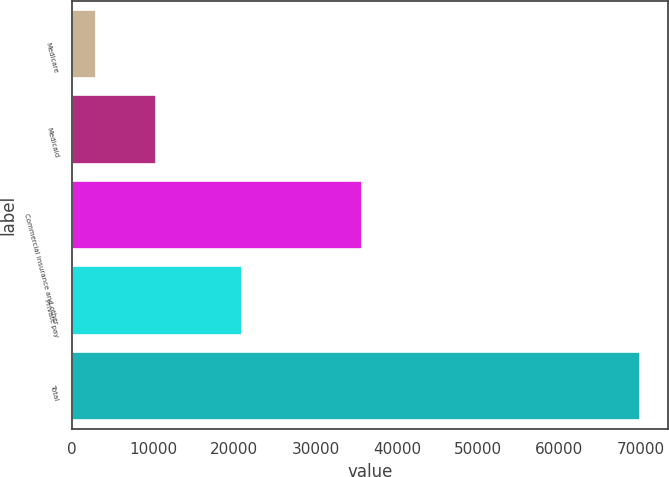Convert chart to OTSL. <chart><loc_0><loc_0><loc_500><loc_500><bar_chart><fcel>Medicare<fcel>Medicaid<fcel>Commercial insurance and other<fcel>Private pay<fcel>Total<nl><fcel>2983<fcel>10309<fcel>35671<fcel>20983<fcel>69946<nl></chart> 